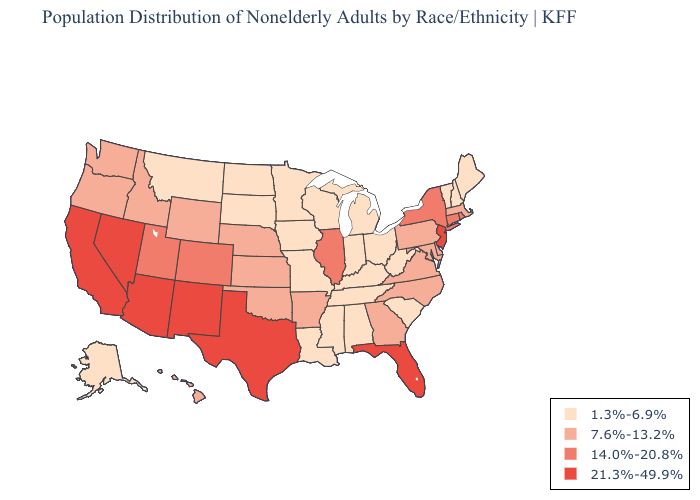Which states have the lowest value in the South?
Give a very brief answer. Alabama, Kentucky, Louisiana, Mississippi, South Carolina, Tennessee, West Virginia. Name the states that have a value in the range 14.0%-20.8%?
Give a very brief answer. Colorado, Connecticut, Illinois, New York, Rhode Island, Utah. Name the states that have a value in the range 14.0%-20.8%?
Short answer required. Colorado, Connecticut, Illinois, New York, Rhode Island, Utah. Name the states that have a value in the range 14.0%-20.8%?
Keep it brief. Colorado, Connecticut, Illinois, New York, Rhode Island, Utah. Which states have the lowest value in the USA?
Give a very brief answer. Alabama, Alaska, Indiana, Iowa, Kentucky, Louisiana, Maine, Michigan, Minnesota, Mississippi, Missouri, Montana, New Hampshire, North Dakota, Ohio, South Carolina, South Dakota, Tennessee, Vermont, West Virginia, Wisconsin. What is the lowest value in the USA?
Be succinct. 1.3%-6.9%. What is the highest value in states that border Massachusetts?
Quick response, please. 14.0%-20.8%. Does Indiana have the lowest value in the MidWest?
Write a very short answer. Yes. Which states have the lowest value in the USA?
Answer briefly. Alabama, Alaska, Indiana, Iowa, Kentucky, Louisiana, Maine, Michigan, Minnesota, Mississippi, Missouri, Montana, New Hampshire, North Dakota, Ohio, South Carolina, South Dakota, Tennessee, Vermont, West Virginia, Wisconsin. Which states have the lowest value in the Northeast?
Quick response, please. Maine, New Hampshire, Vermont. What is the value of Arkansas?
Answer briefly. 7.6%-13.2%. Name the states that have a value in the range 21.3%-49.9%?
Write a very short answer. Arizona, California, Florida, Nevada, New Jersey, New Mexico, Texas. What is the value of Louisiana?
Give a very brief answer. 1.3%-6.9%. Among the states that border Virginia , does Maryland have the lowest value?
Quick response, please. No. Does the map have missing data?
Concise answer only. No. 